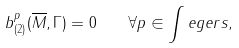Convert formula to latex. <formula><loc_0><loc_0><loc_500><loc_500>b ^ { p } _ { ( 2 ) } ( \overline { M } , \Gamma ) = 0 \quad \forall p \in \int e g e r s ,</formula> 